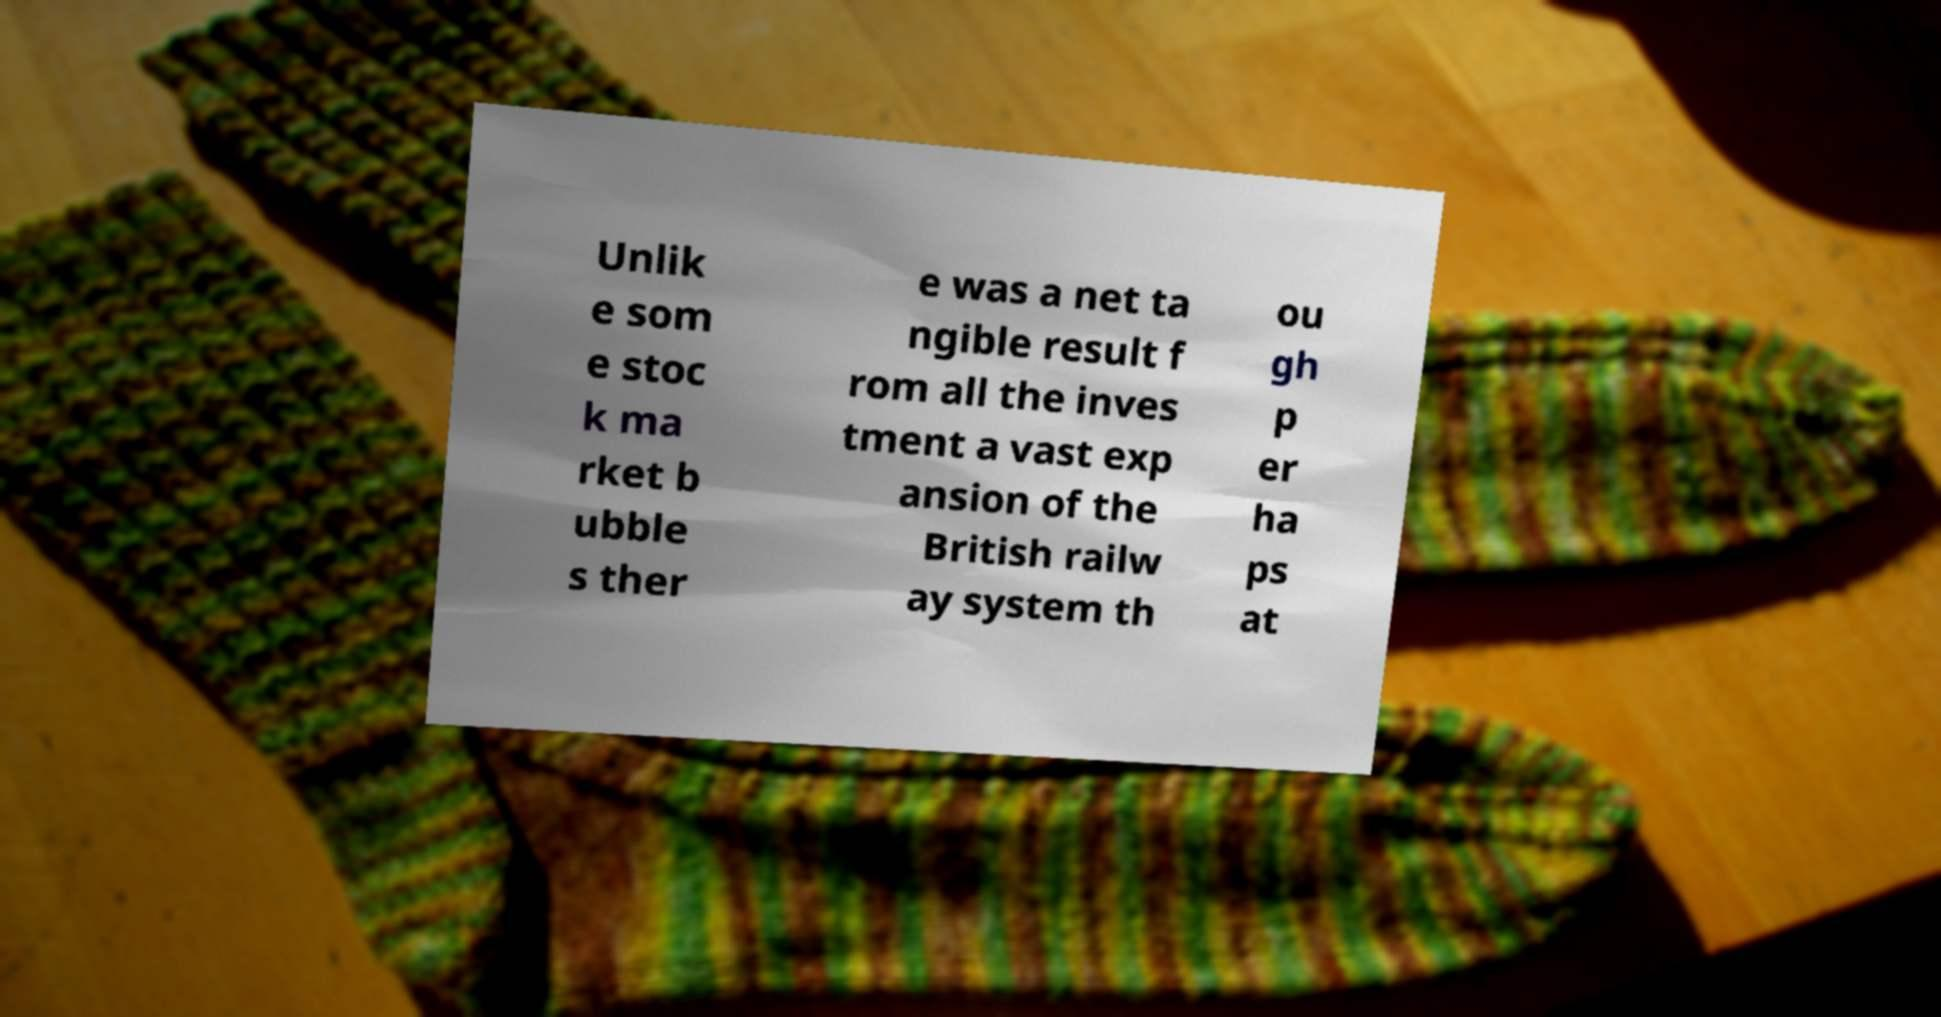Can you read and provide the text displayed in the image?This photo seems to have some interesting text. Can you extract and type it out for me? Unlik e som e stoc k ma rket b ubble s ther e was a net ta ngible result f rom all the inves tment a vast exp ansion of the British railw ay system th ou gh p er ha ps at 